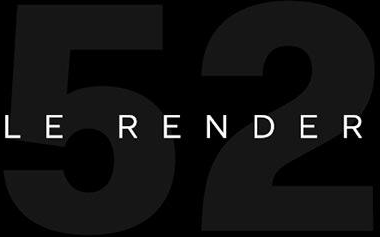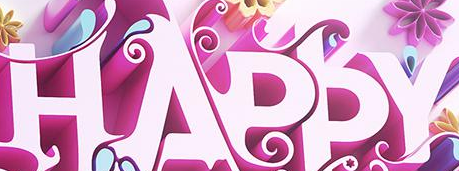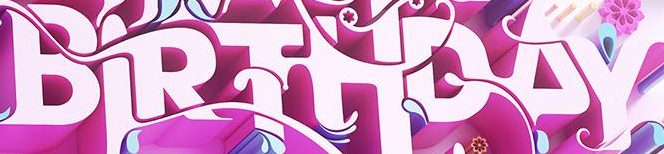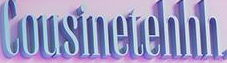What words can you see in these images in sequence, separated by a semicolon? 52; HAPPY; BIRTHDAY; Cousinetehhh 